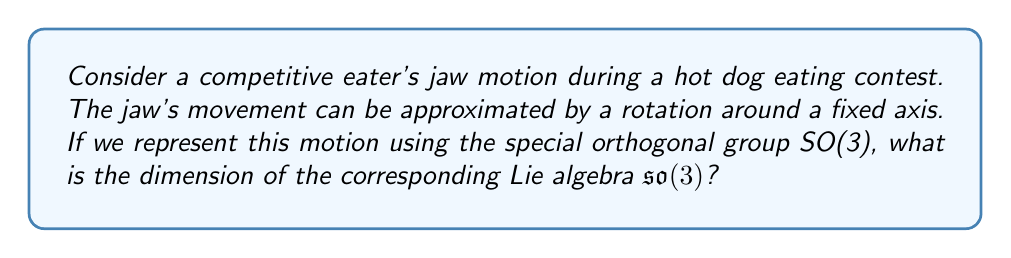Provide a solution to this math problem. To solve this problem, let's follow these steps:

1) The special orthogonal group SO(3) represents all rotations in 3D space. In our case, it models the rotation of the jaw around a fixed axis.

2) The Lie algebra $\mathfrak{so}(3)$ is associated with the Lie group SO(3). It represents the infinitesimal generators of the group.

3) To find the dimension of $\mathfrak{so}(3)$, we need to consider the structure of SO(3):
   
   SO(3) consists of 3x3 orthogonal matrices with determinant 1.

4) The dimension of a Lie algebra is equal to the dimension of the corresponding Lie group as a manifold.

5) To calculate the dimension of SO(3), we count the number of independent parameters:
   
   - A 3x3 matrix has 9 entries
   - The orthogonality condition $AA^T = I$ gives 6 constraints
   - The determinant condition det(A) = 1 gives 1 more constraint

6) Therefore, the number of free parameters is:
   
   9 - 6 - 1 = 2

7) However, this calculation misses one degree of freedom. The correct dimension is actually 3, which corresponds to the three independent rotation axes in 3D space.

8) Thus, the dimension of the Lie algebra $\mathfrak{so}(3)$ is 3.

This 3-dimensional space aligns well with the competitive eater's jaw motion, which can involve complex 3D rotations during rapid eating techniques.
Answer: 3 